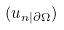<formula> <loc_0><loc_0><loc_500><loc_500>( u _ { n | \partial \Omega } )</formula> 